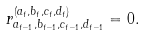Convert formula to latex. <formula><loc_0><loc_0><loc_500><loc_500>r _ { a _ { t - 1 } , b _ { t - 1 } , c _ { t - 1 } , d _ { t - 1 } } ^ { ( a _ { t } , b _ { t } , c _ { t } , d _ { t } ) } = 0 .</formula> 